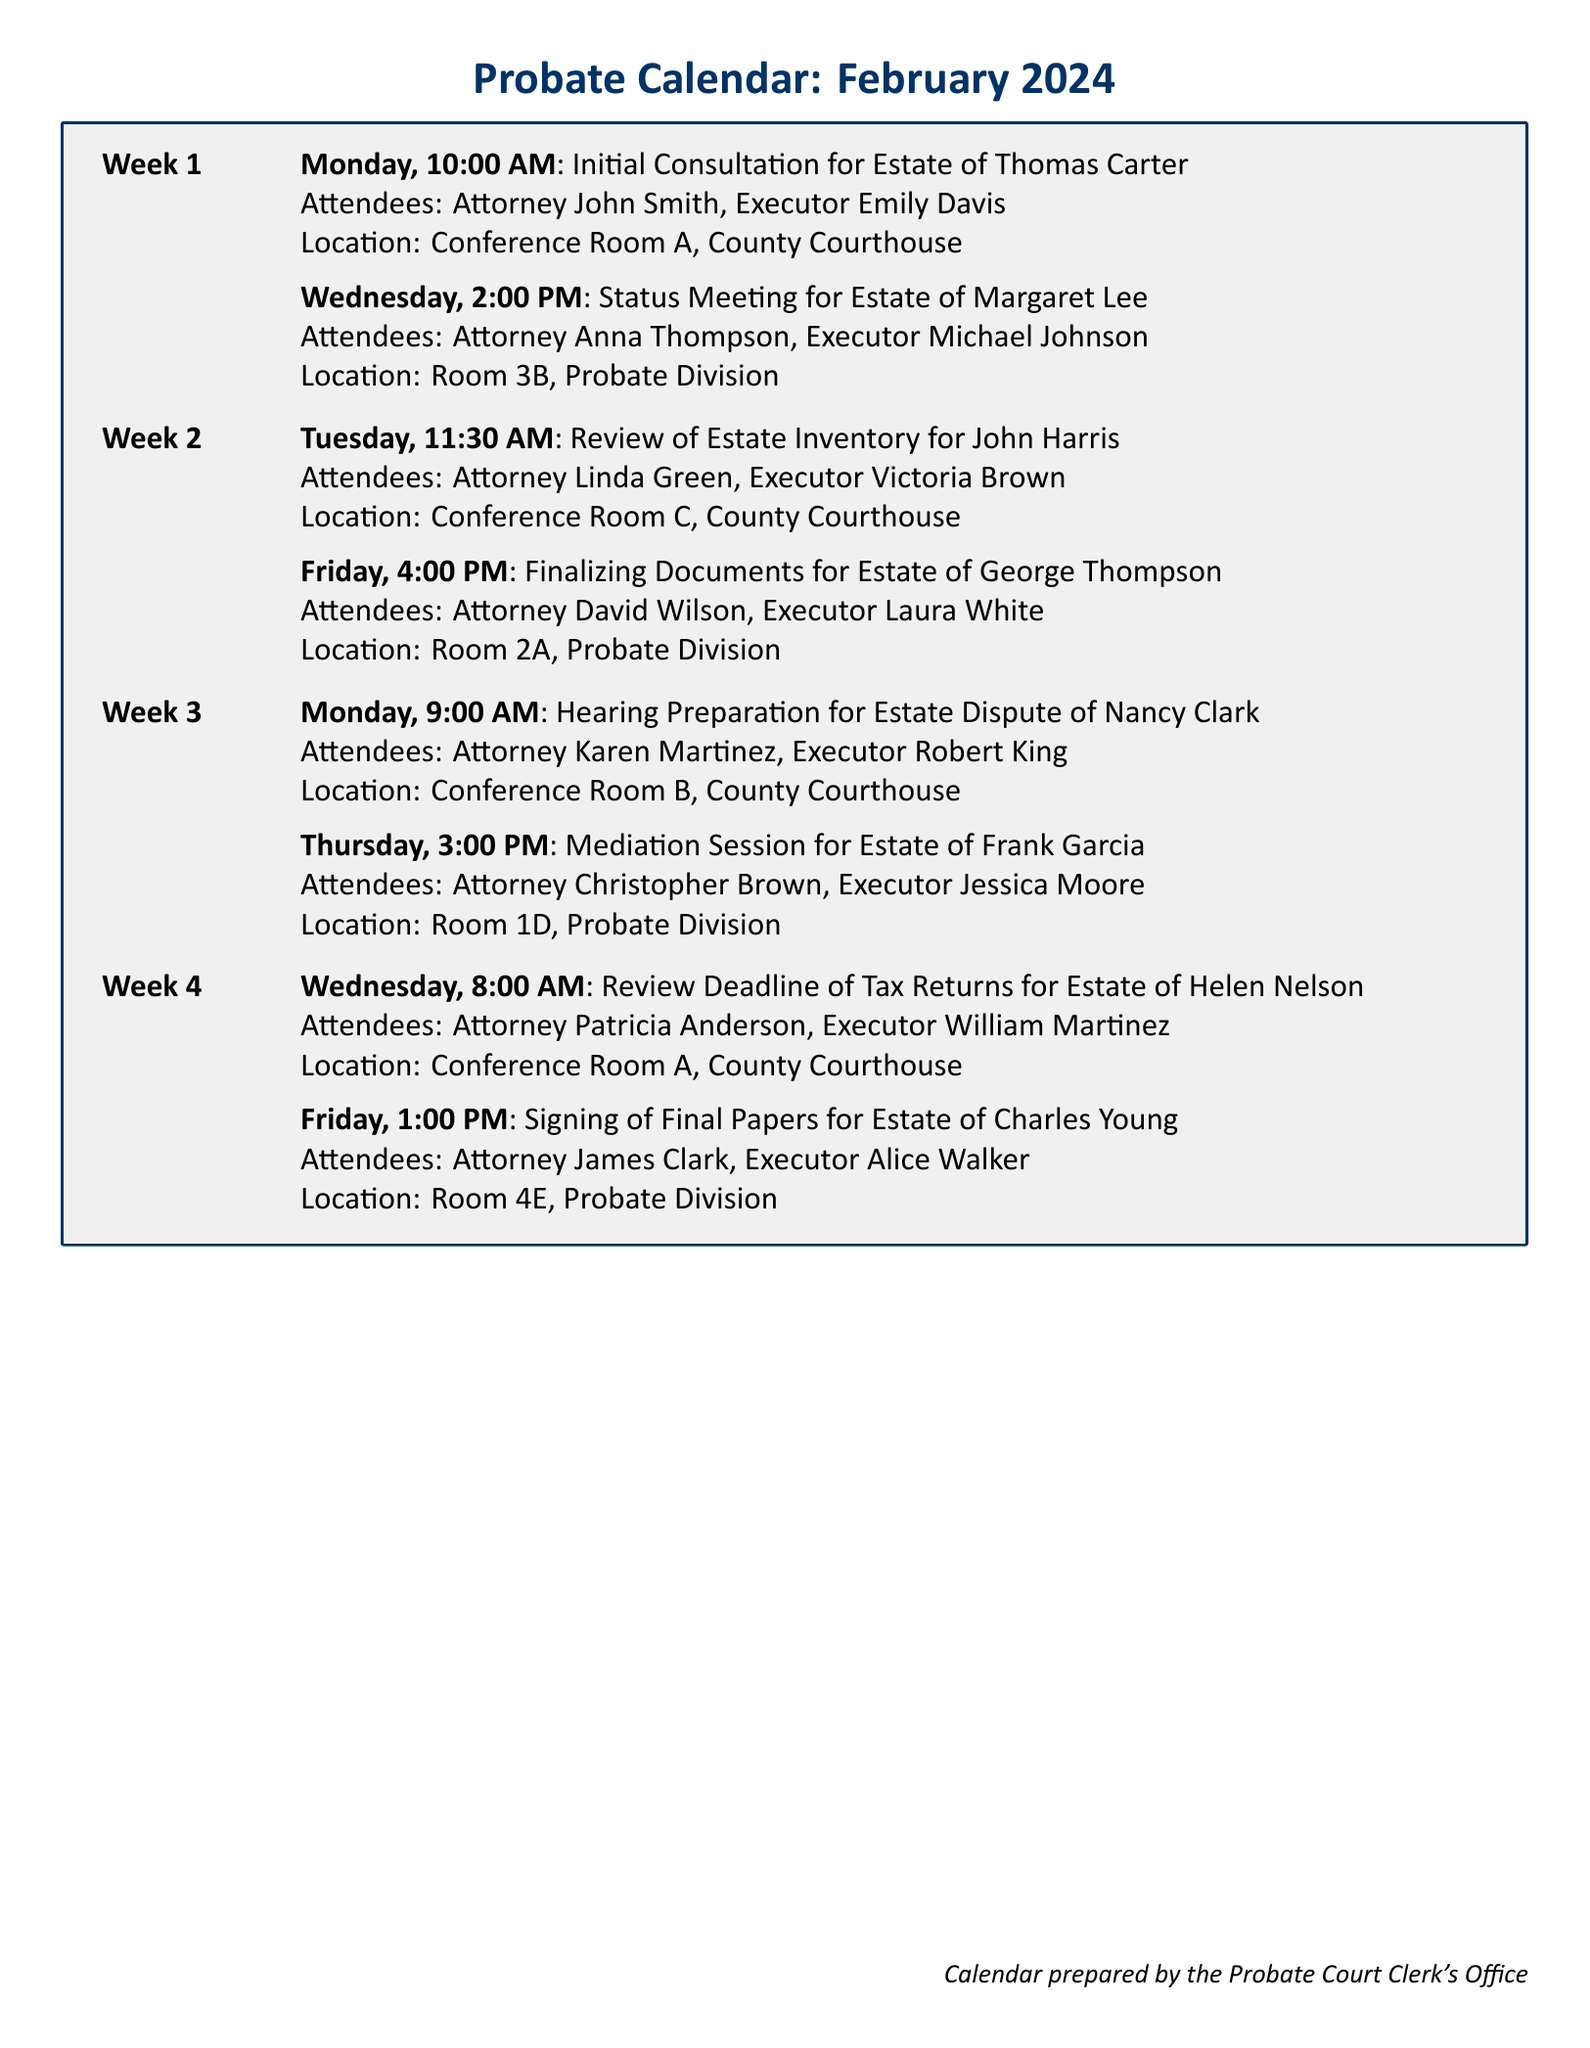What is the first appointment in February 2024? The first appointment is the initial consultation for the Estate of Thomas Carter, scheduled for Monday at 10:00 AM.
Answer: Initial Consultation for Estate of Thomas Carter Who is the executor for the estate of Margaret Lee? The executor for the estate of Margaret Lee is Michael Johnson, who is listed in the status meeting as an attendee.
Answer: Michael Johnson What time is the mediation session for the estate of Frank Garcia? The mediation session is scheduled for Thursday at 3:00 PM, as stated in the calendar.
Answer: 3:00 PM How many appointments are scheduled for the second week of February? There are two appointments scheduled in the second week, as shown in the document.
Answer: 2 Which attorney is meeting on the last appointment day of February 2024? The attorney meeting on the last appointment day (Friday) is James Clark for the signing of final papers for the estate of Charles Young.
Answer: James Clark What is the location for the review deadline of tax returns meeting? The location for the review deadline of tax returns meeting is Conference Room A, as indicated in the document.
Answer: Conference Room A Who is the executor attending the hearing preparation for Nancy Clark's estate? The executor attending is Robert King, as noted in the hearing preparation details.
Answer: Robert King What are the titles of all planned appointments during the fourth week? The titles of the planned appointments are “Review Deadline of Tax Returns for Estate of Helen Nelson” and “Signing of Final Papers for Estate of Charles Young.”
Answer: Review Deadline of Tax Returns for Estate of Helen Nelson, Signing of Final Papers for Estate of Charles Young 